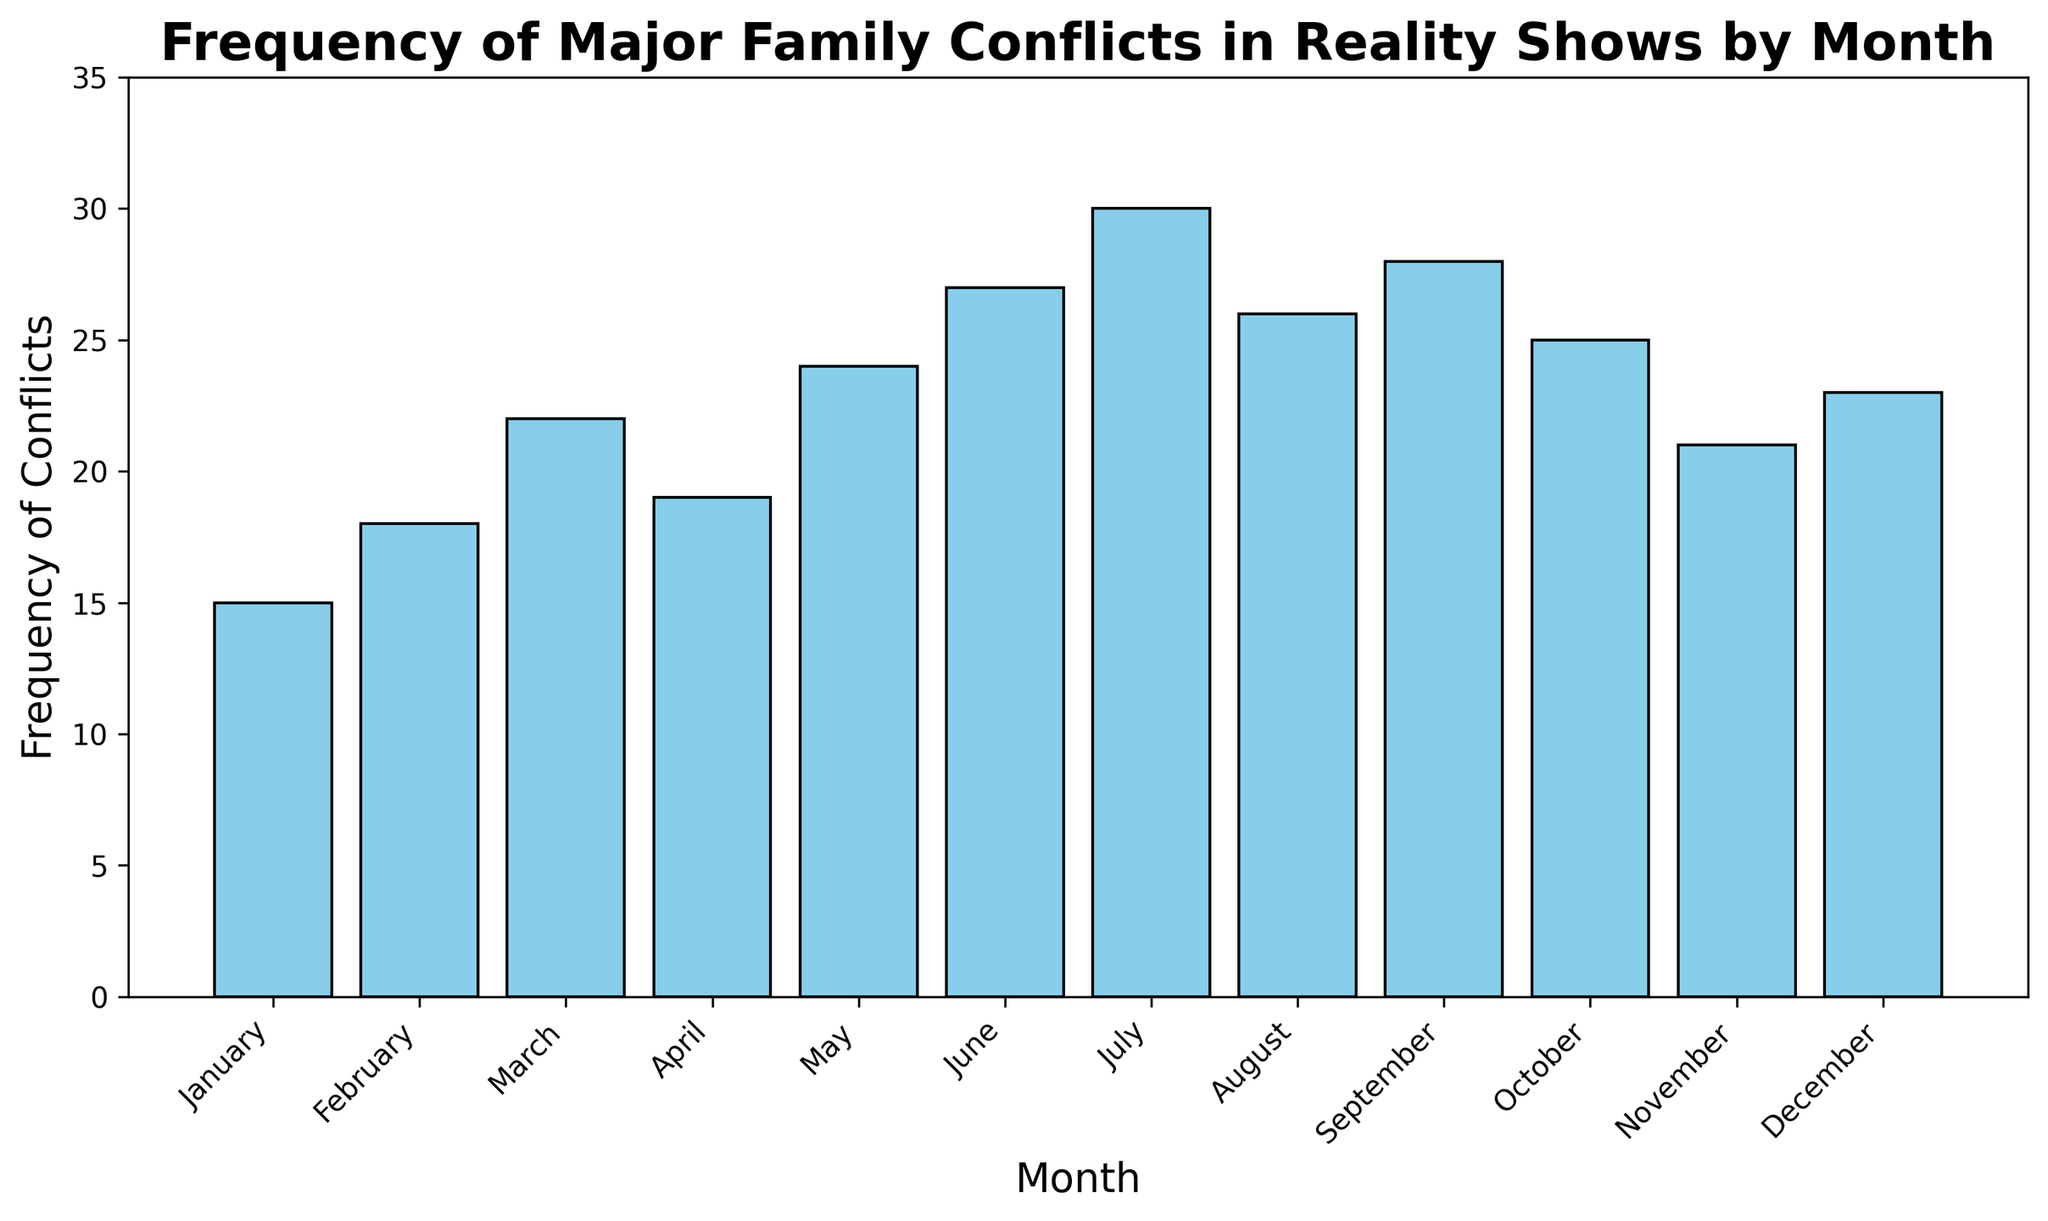Which month has the highest frequency of major family conflicts? The highest bar in the chart represents the month with the highest frequency. July has the tallest bar, indicating the highest conflicts.
Answer: July How many more conflicts occurred in July compared to January? July has 30 conflicts and January has 15. Subtract January's conflicts from July's: 30 - 15 = 15.
Answer: 15 What is the total number of conflicts reported from January to December? Sum the number of conflicts for each month: 15 + 18 + 22 + 19 + 24 + 27 + 30 + 26 + 28 + 25 + 21 + 23 = 278.
Answer: 278 Which months have a frequency of conflicts greater than 25? The bars for July, September, August, June, October, and May exceed the 25 mark.
Answer: July, September, August, June, October, May Does any month have the same frequency of conflicts as July? No other bar matches the height of July's bar, which represents 30 conflicts.
Answer: No What is the average monthly frequency of conflicts over the year? Sum the monthly frequencies and divide by 12: (15 + 18 + 22 + 19 + 24 + 27 + 30 + 26 + 28 + 25 + 21 + 23) / 12 = 278 / 12 ≈ 23.17.
Answer: 23.17 Which month saw the highest increase in conflicts from the previous month? Calculate the difference in conflicts from one month to the next and find the greatest increase: Feb-Jan = 18-15 = 3, Mar-Feb = 22-18 = 4, Apr-Mar = 19-22 = -3, May-Apr = 24-19 = 5, Jun-May = 27-24 = 3, Jul-Jun = 30-27 = 3, Aug-Jul = 26-30 = -4, Sept-Aug = 28-26 = 2, Oct-Sept = 25-28 = -3, Nov-Oct = 21-25 = -4, Dec-Nov = 23-21 = 2; May saw the highest increase of 5.
Answer: May Which quarter of the year had the highest total frequency of conflicts? Divide the months into quarters and sum the conflicts for each quarter: Q1 (Jan, Feb, Mar) = 15+18+22 = 55, Q2 (Apr, May, Jun) = 19+24+27 = 70, Q3 (Jul, Aug, Sept) = 30+26+28 = 84, Q4 (Oct, Nov, Dec) = 25+21+23 = 69. Q3 has the highest sum, 84.
Answer: Q3 How does the frequency of conflicts in December compare to November? December's bar is taller than November's. Specifically, December has 23 conflicts and November has 21. Therefore, December has 2 more conflicts than November.
Answer: December is higher by 2 Is there any consistent trend in the frequency of conflicts over the year? Overall, there's a fluctuating upward trend with peaks around the mid-year (June, July). The frequency increases from January through July, dips in August, fluctuates slightly through the end of the year.
Answer: Yes, upward trend with mid-year peak 